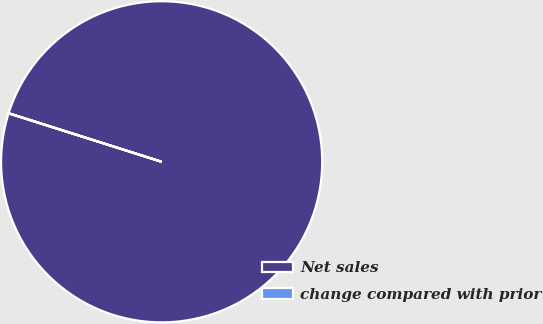<chart> <loc_0><loc_0><loc_500><loc_500><pie_chart><fcel>Net sales<fcel>change compared with prior<nl><fcel>99.98%<fcel>0.02%<nl></chart> 